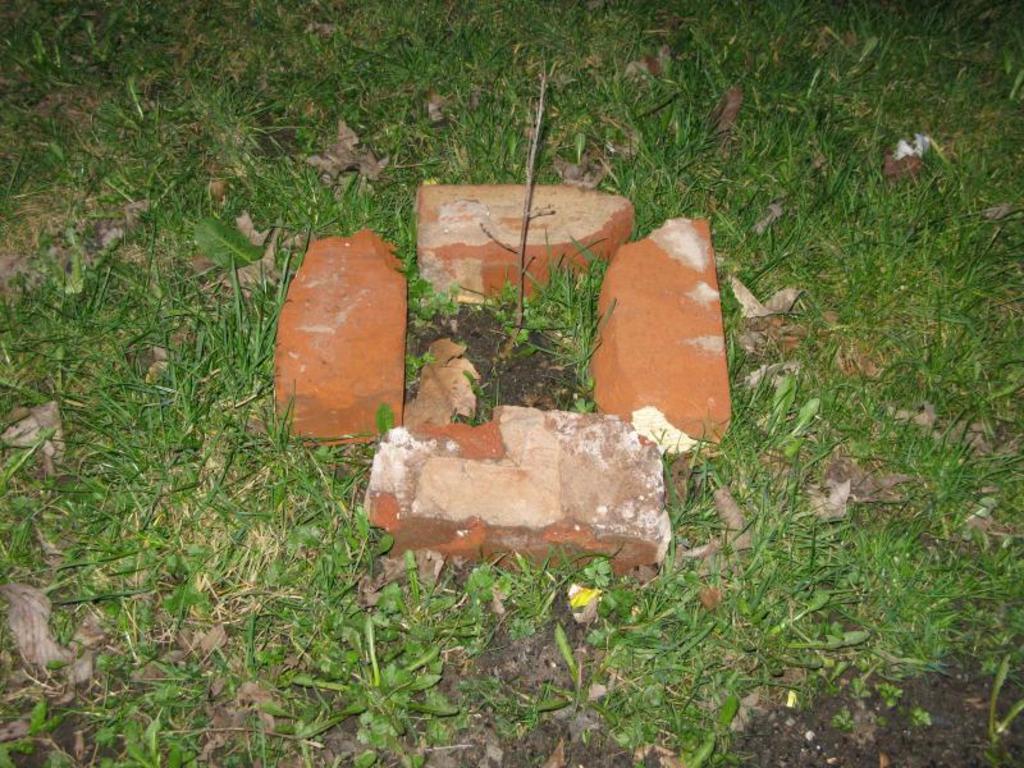Can you describe this image briefly? In the center of the image there is a plant. Around the plant there are bricks. At the bottom of the image there is grass on the surface. 